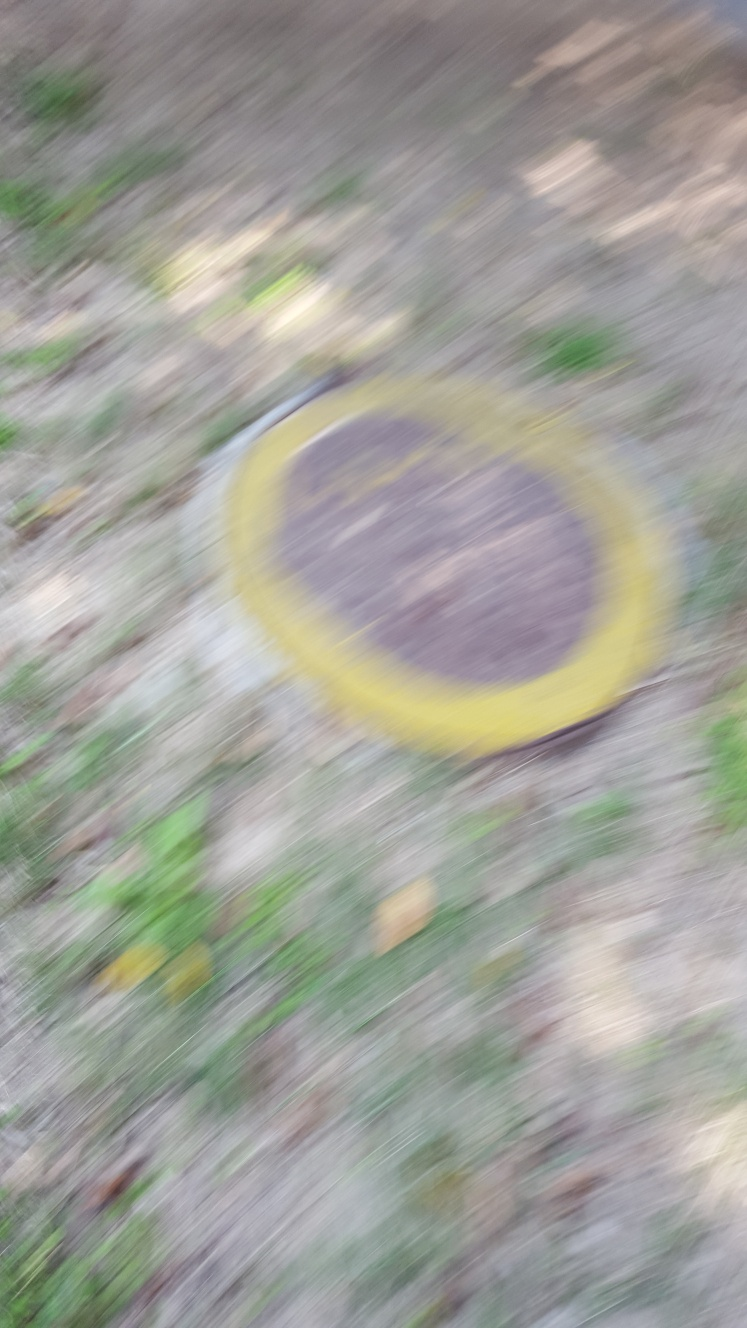Can you tell what the blurred object in the center might be? Even though the image is blurry, the object in the center appears to be round and yellow with a darker middle, which could possibly be a sign or disc lying on the ground. The surrounding greenery suggests it could be outdoors. 